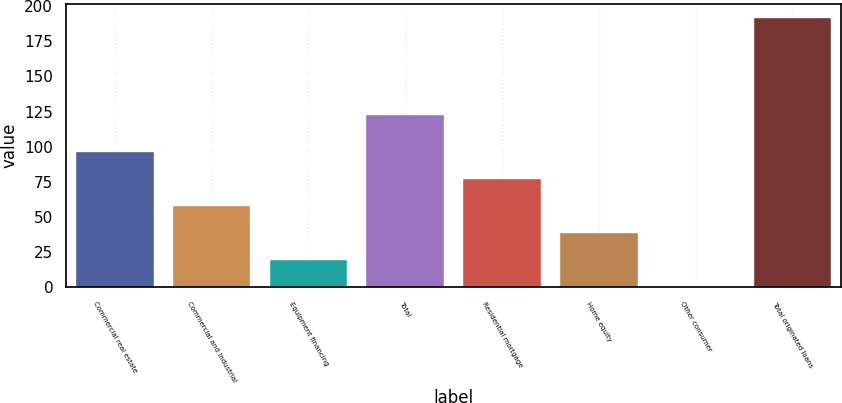Convert chart. <chart><loc_0><loc_0><loc_500><loc_500><bar_chart><fcel>Commercial real estate<fcel>Commercial and industrial<fcel>Equipment financing<fcel>Total<fcel>Residential mortgage<fcel>Home equity<fcel>Other consumer<fcel>Total originated loans<nl><fcel>96<fcel>57.72<fcel>19.44<fcel>122.2<fcel>76.86<fcel>38.58<fcel>0.3<fcel>191.7<nl></chart> 